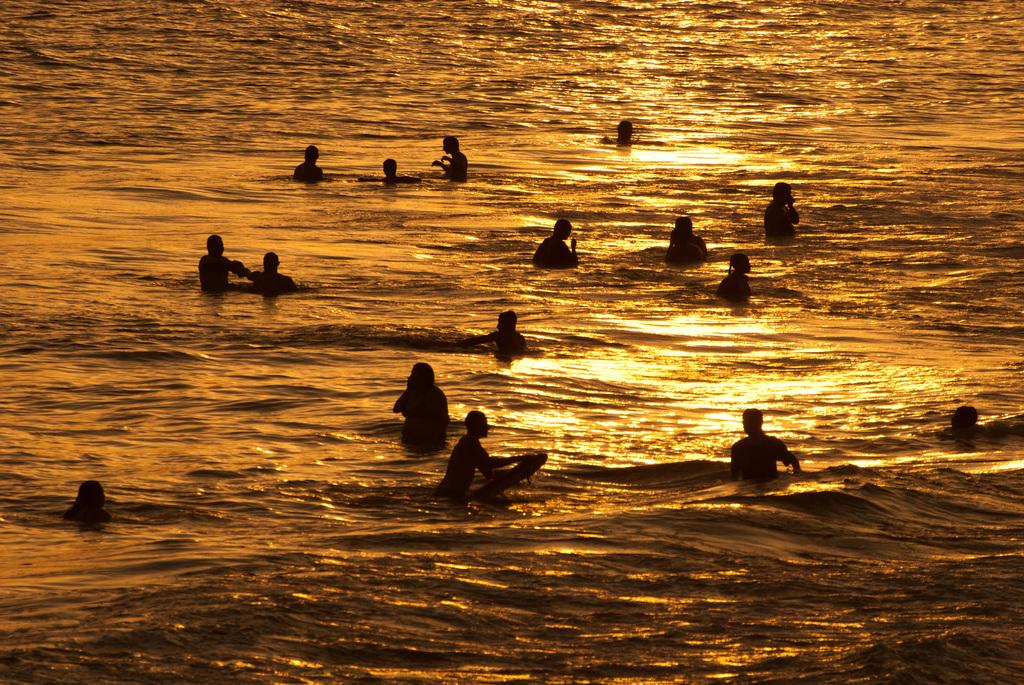Who or what can be seen in the image? There are people in the image. What are the people doing in the image? The people are swimming in the water. What type of pie is being used by the people in the image? There is no pie present in the image; the people are swimming in the water. What is the purpose of the quiver in the image? There is no quiver present in the image; it is a swimming scene with people in the water. 